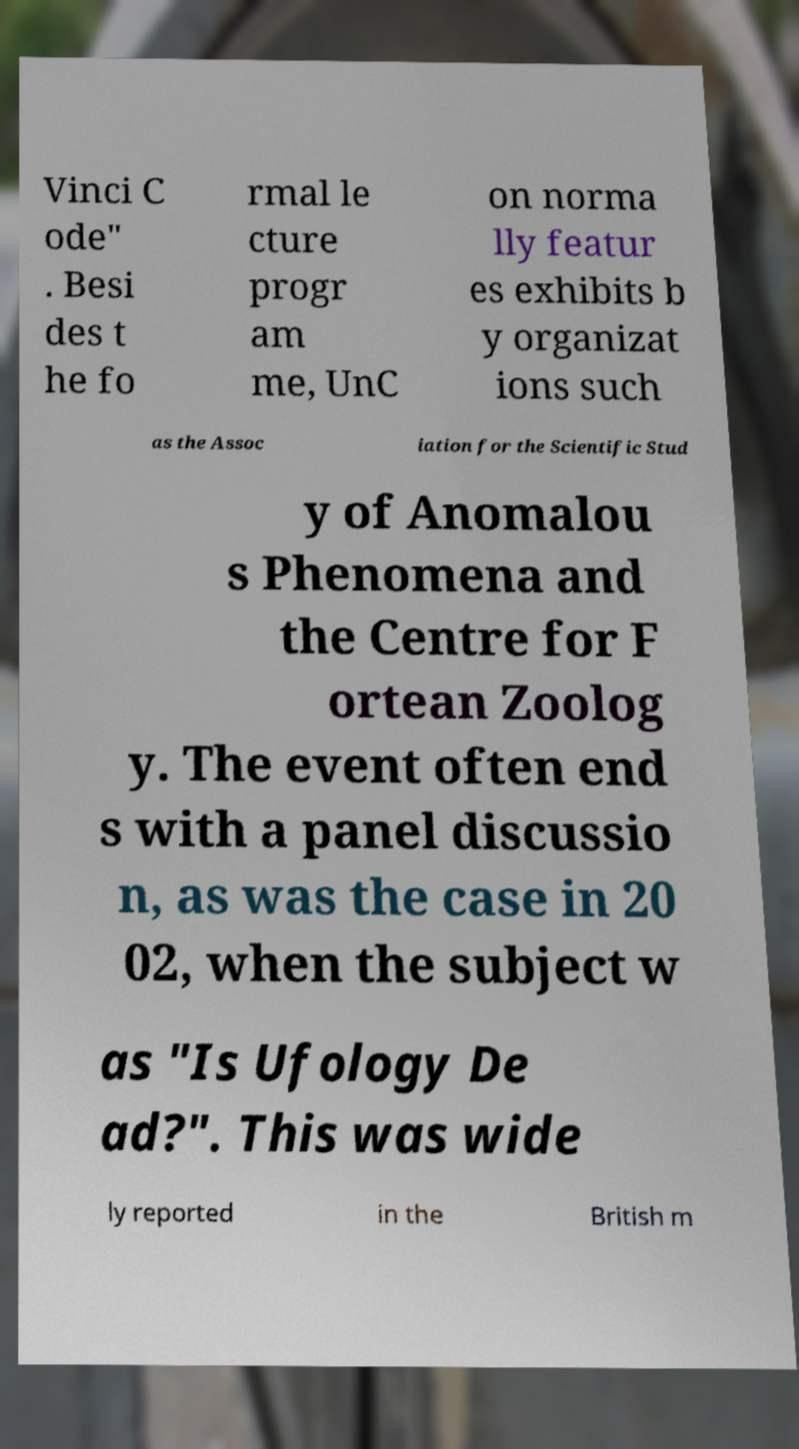Can you read and provide the text displayed in the image?This photo seems to have some interesting text. Can you extract and type it out for me? Vinci C ode" . Besi des t he fo rmal le cture progr am me, UnC on norma lly featur es exhibits b y organizat ions such as the Assoc iation for the Scientific Stud y of Anomalou s Phenomena and the Centre for F ortean Zoolog y. The event often end s with a panel discussio n, as was the case in 20 02, when the subject w as "Is Ufology De ad?". This was wide ly reported in the British m 